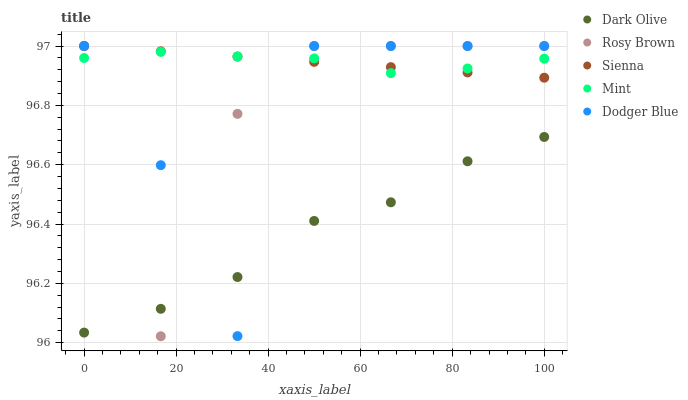Does Dark Olive have the minimum area under the curve?
Answer yes or no. Yes. Does Mint have the maximum area under the curve?
Answer yes or no. Yes. Does Dodger Blue have the minimum area under the curve?
Answer yes or no. No. Does Dodger Blue have the maximum area under the curve?
Answer yes or no. No. Is Sienna the smoothest?
Answer yes or no. Yes. Is Dodger Blue the roughest?
Answer yes or no. Yes. Is Rosy Brown the smoothest?
Answer yes or no. No. Is Rosy Brown the roughest?
Answer yes or no. No. Does Rosy Brown have the lowest value?
Answer yes or no. Yes. Does Dodger Blue have the lowest value?
Answer yes or no. No. Does Rosy Brown have the highest value?
Answer yes or no. Yes. Does Dark Olive have the highest value?
Answer yes or no. No. Is Dark Olive less than Sienna?
Answer yes or no. Yes. Is Sienna greater than Dark Olive?
Answer yes or no. Yes. Does Mint intersect Sienna?
Answer yes or no. Yes. Is Mint less than Sienna?
Answer yes or no. No. Is Mint greater than Sienna?
Answer yes or no. No. Does Dark Olive intersect Sienna?
Answer yes or no. No. 